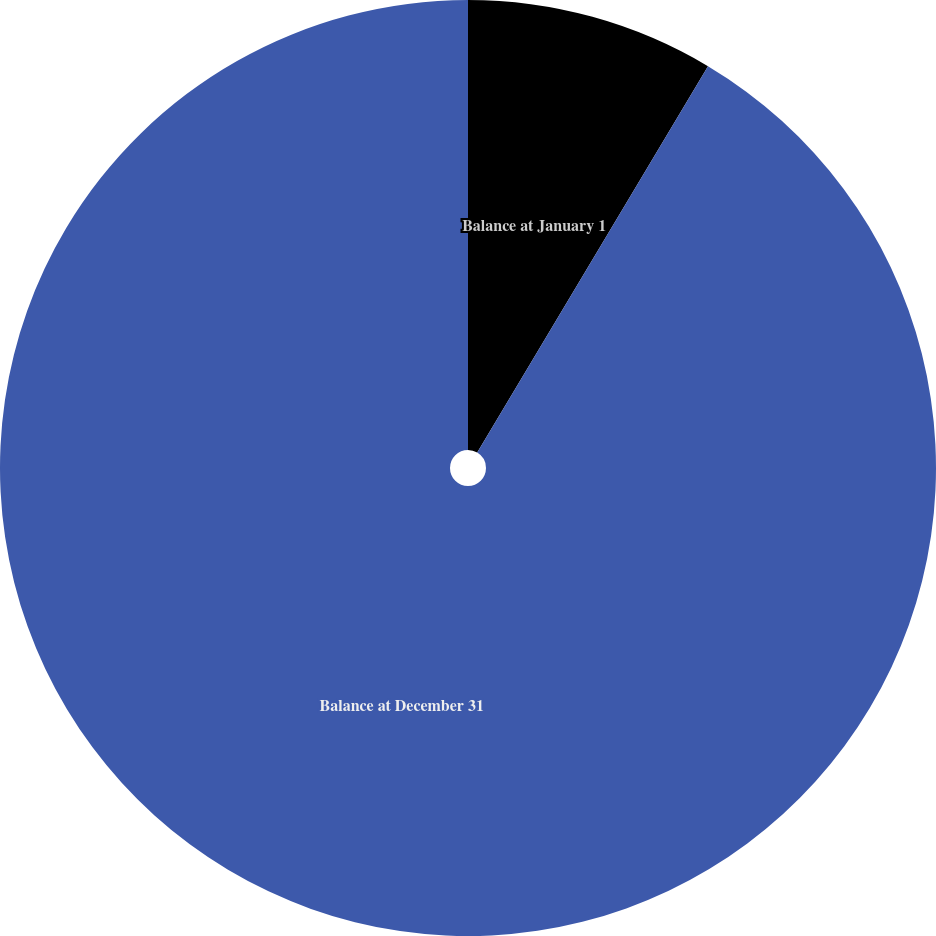Convert chart to OTSL. <chart><loc_0><loc_0><loc_500><loc_500><pie_chart><fcel>Balance at January 1<fcel>Balance at December 31<nl><fcel>8.57%<fcel>91.43%<nl></chart> 